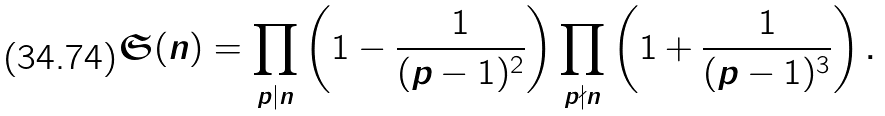<formula> <loc_0><loc_0><loc_500><loc_500>\mathfrak S ( n ) = \prod _ { p | n } \left ( 1 - \frac { 1 } { ( p - 1 ) ^ { 2 } } \right ) \prod _ { p \nmid n } \left ( 1 + \frac { 1 } { ( p - 1 ) ^ { 3 } } \right ) .</formula> 